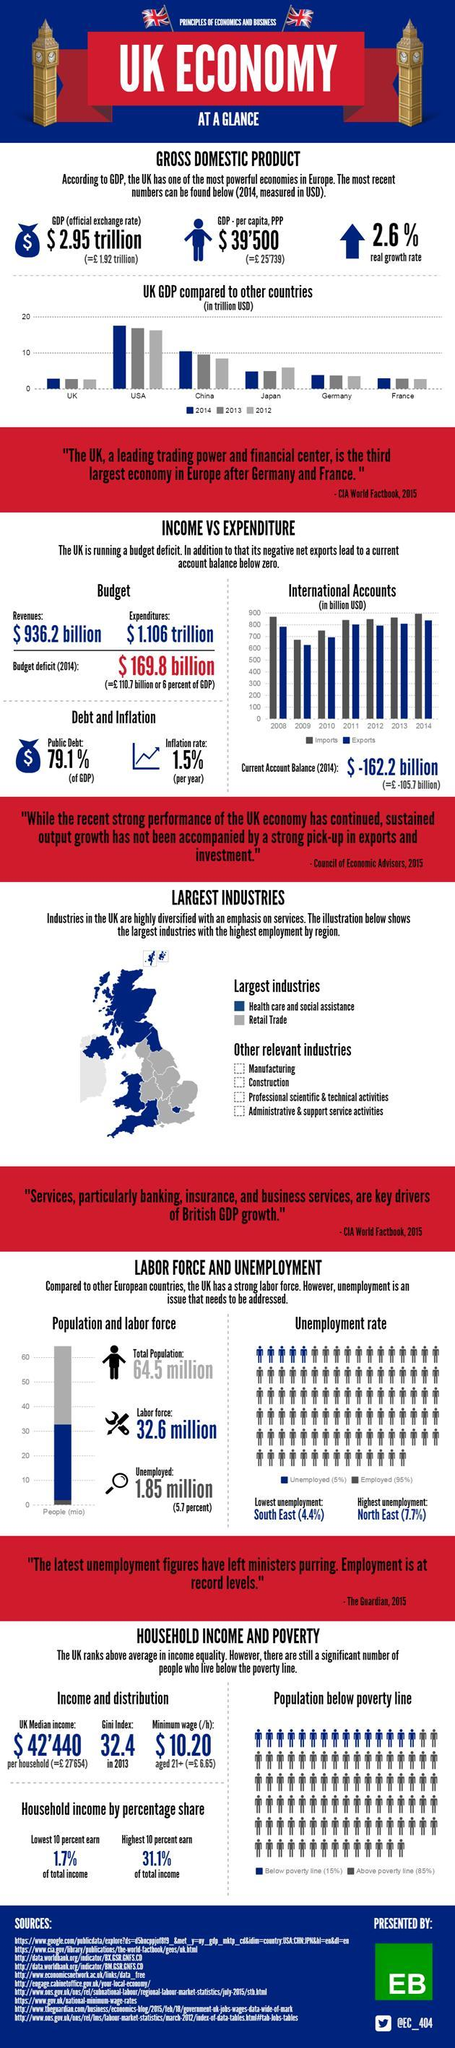By what percent is a rate of unemployment in the North East of UK, higher than that of the South East?
Answer the question with a short phrase. 3.3% How many industries are mentioned under 'other relevant industries'? 4 What is the current account balance for the year 2014 (in pounds)? 105.7 billion Which region in UK shows the highest unemployment? North East In which year did UK have the lowest imports and exports? 2009 What is the real growth rate in UK for the year 2014? 2.6% What is the per capita GDP of UK in the year 2014 (in pounds)? 25'739 What colour is used to represent 'health care and social assistance' - white, blue, grey or red? Blue What is UK's budget deficit for the year 2014 (in pounds)? 110.7 billion What are the two main industries, shown on the map? Health care and social assistance, Retail trade What is UK's Gini index in 2013? 32.4 What is the per annum rate of inflation? 1.5% Which country stands second highest with regard to GDP? China 